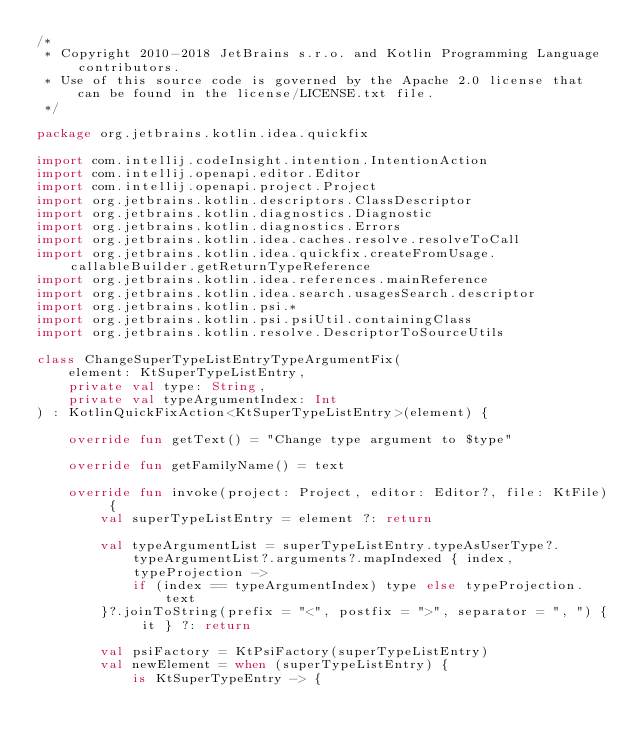<code> <loc_0><loc_0><loc_500><loc_500><_Kotlin_>/*
 * Copyright 2010-2018 JetBrains s.r.o. and Kotlin Programming Language contributors.
 * Use of this source code is governed by the Apache 2.0 license that can be found in the license/LICENSE.txt file.
 */

package org.jetbrains.kotlin.idea.quickfix

import com.intellij.codeInsight.intention.IntentionAction
import com.intellij.openapi.editor.Editor
import com.intellij.openapi.project.Project
import org.jetbrains.kotlin.descriptors.ClassDescriptor
import org.jetbrains.kotlin.diagnostics.Diagnostic
import org.jetbrains.kotlin.diagnostics.Errors
import org.jetbrains.kotlin.idea.caches.resolve.resolveToCall
import org.jetbrains.kotlin.idea.quickfix.createFromUsage.callableBuilder.getReturnTypeReference
import org.jetbrains.kotlin.idea.references.mainReference
import org.jetbrains.kotlin.idea.search.usagesSearch.descriptor
import org.jetbrains.kotlin.psi.*
import org.jetbrains.kotlin.psi.psiUtil.containingClass
import org.jetbrains.kotlin.resolve.DescriptorToSourceUtils

class ChangeSuperTypeListEntryTypeArgumentFix(
    element: KtSuperTypeListEntry,
    private val type: String,
    private val typeArgumentIndex: Int
) : KotlinQuickFixAction<KtSuperTypeListEntry>(element) {

    override fun getText() = "Change type argument to $type"

    override fun getFamilyName() = text

    override fun invoke(project: Project, editor: Editor?, file: KtFile) {
        val superTypeListEntry = element ?: return

        val typeArgumentList = superTypeListEntry.typeAsUserType?.typeArgumentList?.arguments?.mapIndexed { index, typeProjection ->
            if (index == typeArgumentIndex) type else typeProjection.text
        }?.joinToString(prefix = "<", postfix = ">", separator = ", ") { it } ?: return

        val psiFactory = KtPsiFactory(superTypeListEntry)
        val newElement = when (superTypeListEntry) {
            is KtSuperTypeEntry -> {</code> 